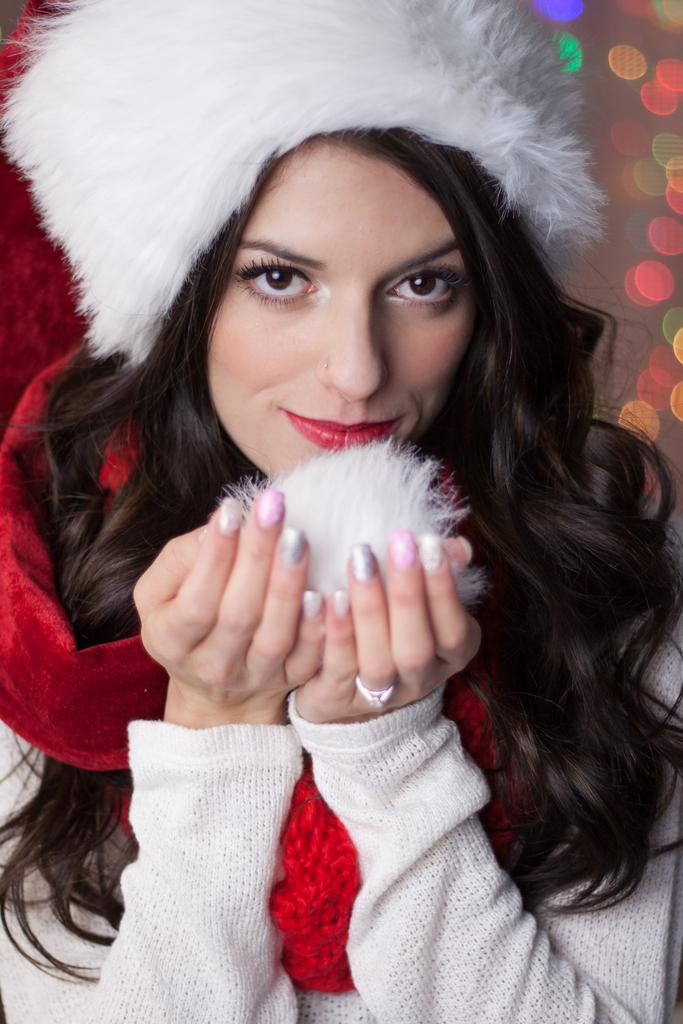What is the main subject of the image? The main subject of the image is a lady. What is the lady holding in her hands? There is an object in the lady's hands. Can you describe the background of the image? The background of the image is blurred. What type of berry can be seen in the lady's breath in the image? There is no berry visible in the lady's breath in the image. Is the lady playing a game of chess in the image? There is no indication of a chess game or any chess pieces in the image. 